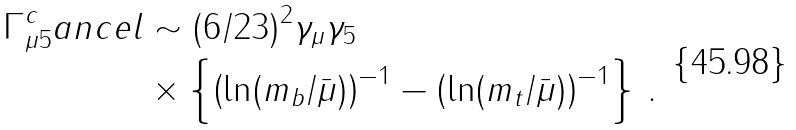<formula> <loc_0><loc_0><loc_500><loc_500>\Gamma _ { \mu 5 } ^ { c } a n c e l & \sim ( 6 / 2 3 ) ^ { 2 } \gamma _ { \mu } \gamma _ { 5 } \\ & \times \left \{ \left ( \ln ( m _ { b } / \bar { \mu } ) \right ) ^ { - 1 } - \left ( \ln ( m _ { t } / \bar { \mu } ) \right ) ^ { - 1 } \right \} \, .</formula> 